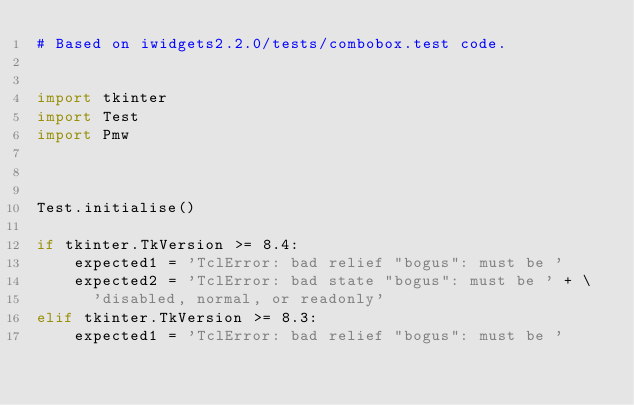<code> <loc_0><loc_0><loc_500><loc_500><_Python_># Based on iwidgets2.2.0/tests/combobox.test code.


import tkinter
import Test
import Pmw


    
Test.initialise()

if tkinter.TkVersion >= 8.4:
    expected1 = 'TclError: bad relief "bogus": must be '
    expected2 = 'TclError: bad state "bogus": must be ' + \
      'disabled, normal, or readonly'
elif tkinter.TkVersion >= 8.3:
    expected1 = 'TclError: bad relief "bogus": must be '</code> 